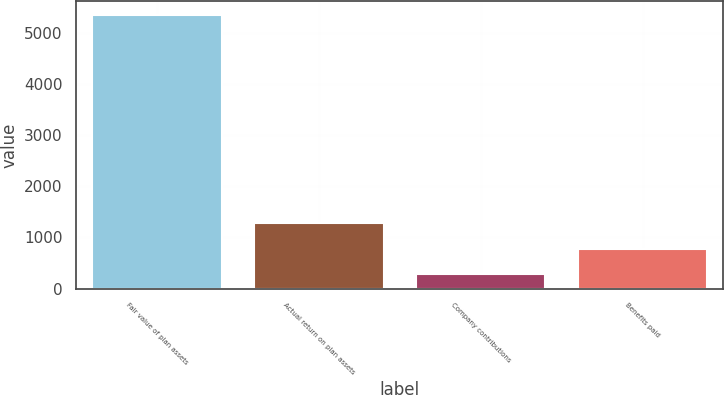Convert chart to OTSL. <chart><loc_0><loc_0><loc_500><loc_500><bar_chart><fcel>Fair value of plan assets<fcel>Actual return on plan assets<fcel>Company contributions<fcel>Benefits paid<nl><fcel>5357<fcel>1291.4<fcel>275<fcel>783.2<nl></chart> 